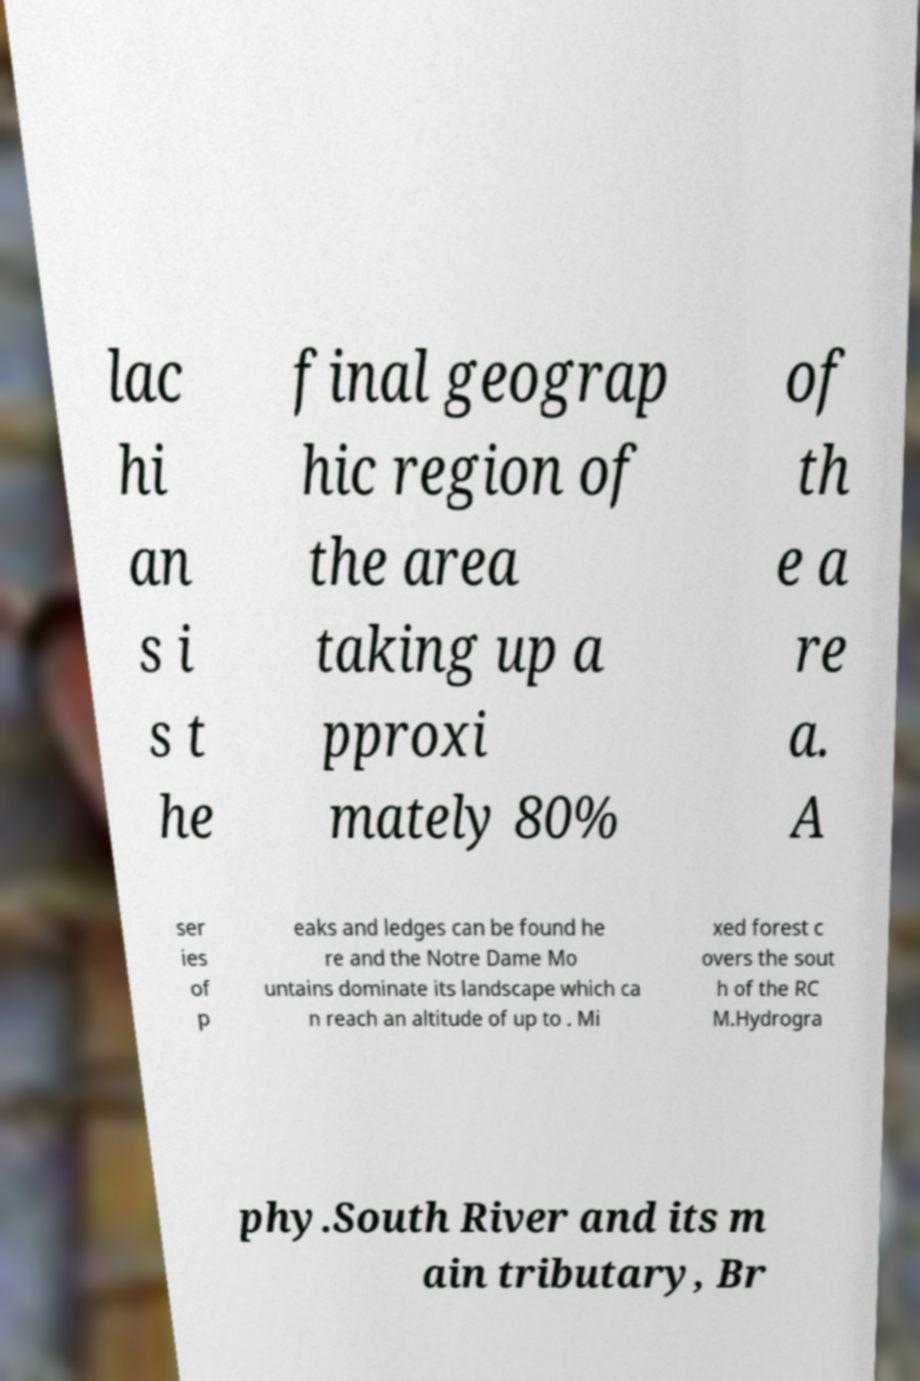I need the written content from this picture converted into text. Can you do that? lac hi an s i s t he final geograp hic region of the area taking up a pproxi mately 80% of th e a re a. A ser ies of p eaks and ledges can be found he re and the Notre Dame Mo untains dominate its landscape which ca n reach an altitude of up to . Mi xed forest c overs the sout h of the RC M.Hydrogra phy.South River and its m ain tributary, Br 